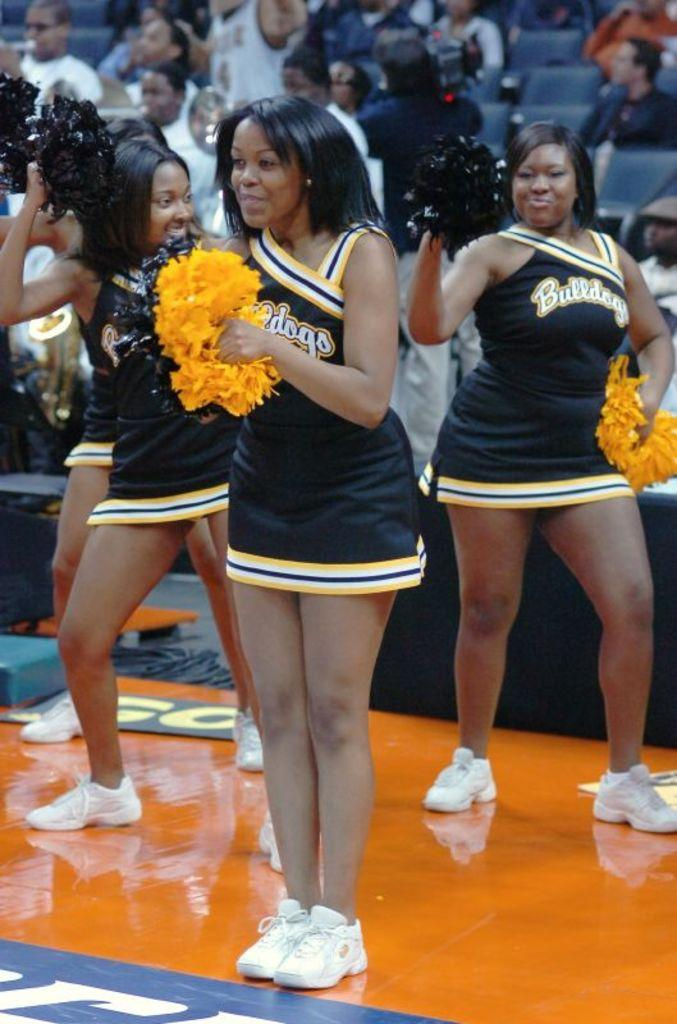<image>
Write a terse but informative summary of the picture. Cheerleaders on the sidelines cheer for the Bulldogs team. 